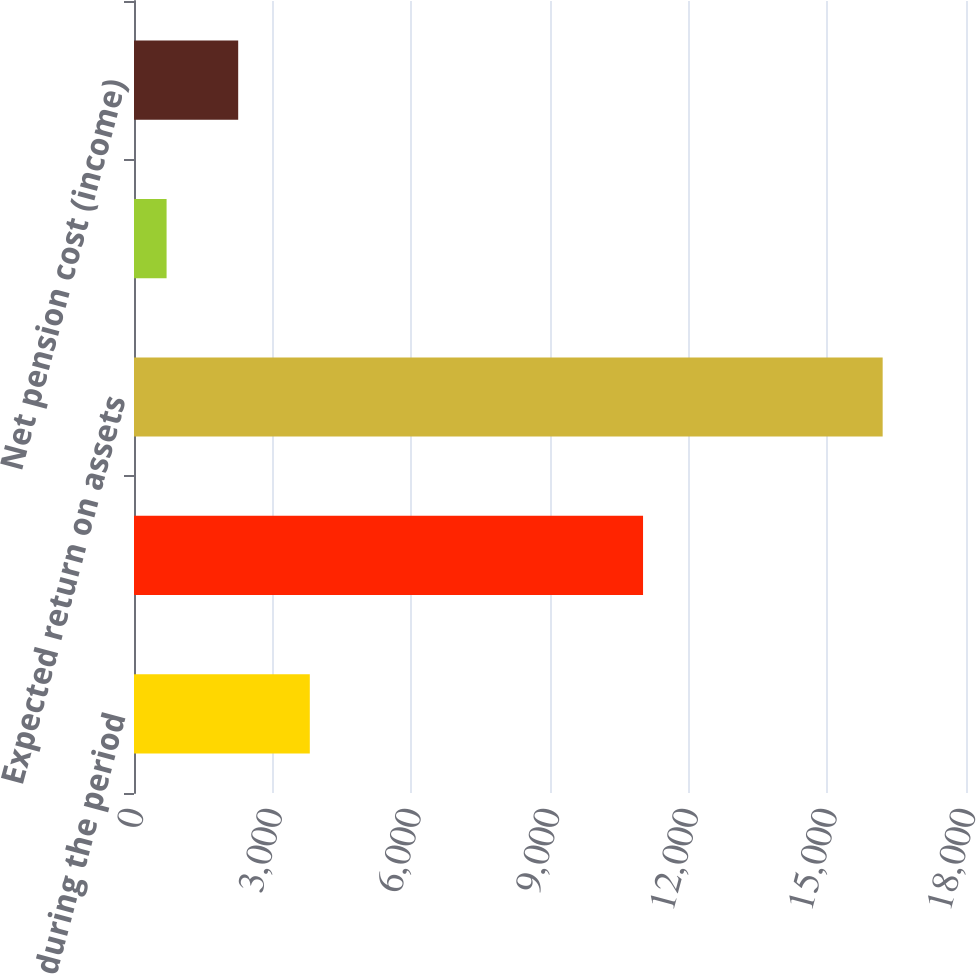Convert chart to OTSL. <chart><loc_0><loc_0><loc_500><loc_500><bar_chart><fcel>during the period<fcel>benefit obligation<fcel>Expected return on assets<fcel>Amortization of prior service<fcel>Net pension cost (income)<nl><fcel>3803.4<fcel>11013<fcel>16197<fcel>705<fcel>2254.2<nl></chart> 